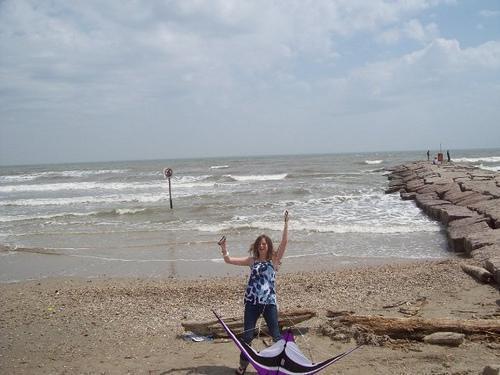How many people are on the beach?
Give a very brief answer. 1. How many people are in the picture?
Give a very brief answer. 1. 